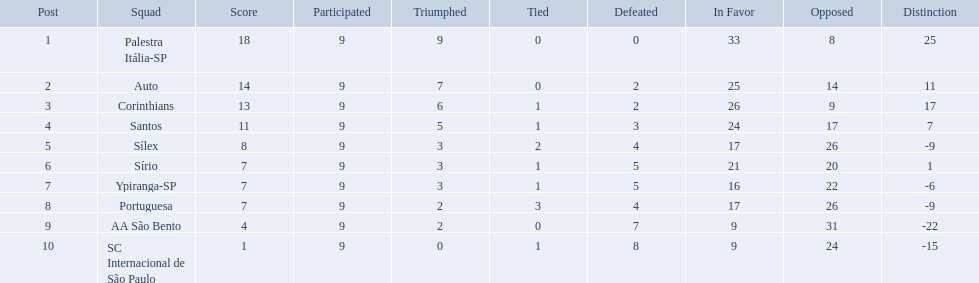How many games did each team play? 9, 9, 9, 9, 9, 9, 9, 9, 9, 9. Can you give me this table in json format? {'header': ['Post', 'Squad', 'Score', 'Participated', 'Triumphed', 'Tied', 'Defeated', 'In Favor', 'Opposed', 'Distinction'], 'rows': [['1', 'Palestra Itália-SP', '18', '9', '9', '0', '0', '33', '8', '25'], ['2', 'Auto', '14', '9', '7', '0', '2', '25', '14', '11'], ['3', 'Corinthians', '13', '9', '6', '1', '2', '26', '9', '17'], ['4', 'Santos', '11', '9', '5', '1', '3', '24', '17', '7'], ['5', 'Sílex', '8', '9', '3', '2', '4', '17', '26', '-9'], ['6', 'Sírio', '7', '9', '3', '1', '5', '21', '20', '1'], ['7', 'Ypiranga-SP', '7', '9', '3', '1', '5', '16', '22', '-6'], ['8', 'Portuguesa', '7', '9', '2', '3', '4', '17', '26', '-9'], ['9', 'AA São Bento', '4', '9', '2', '0', '7', '9', '31', '-22'], ['10', 'SC Internacional de São Paulo', '1', '9', '0', '1', '8', '9', '24', '-15']]} Did any team score 13 points in the total games they played? 13. What is the name of that team? Corinthians. Which teams were playing brazilian football in 1926? Palestra Itália-SP, Auto, Corinthians, Santos, Sílex, Sírio, Ypiranga-SP, Portuguesa, AA São Bento, SC Internacional de São Paulo. Of those teams, which one scored 13 points? Corinthians. Brazilian football in 1926 what teams had no draws? Palestra Itália-SP, Auto, AA São Bento. Of the teams with no draws name the 2 who lost the lease. Palestra Itália-SP, Auto. What team of the 2 who lost the least and had no draws had the highest difference? Palestra Itália-SP. 